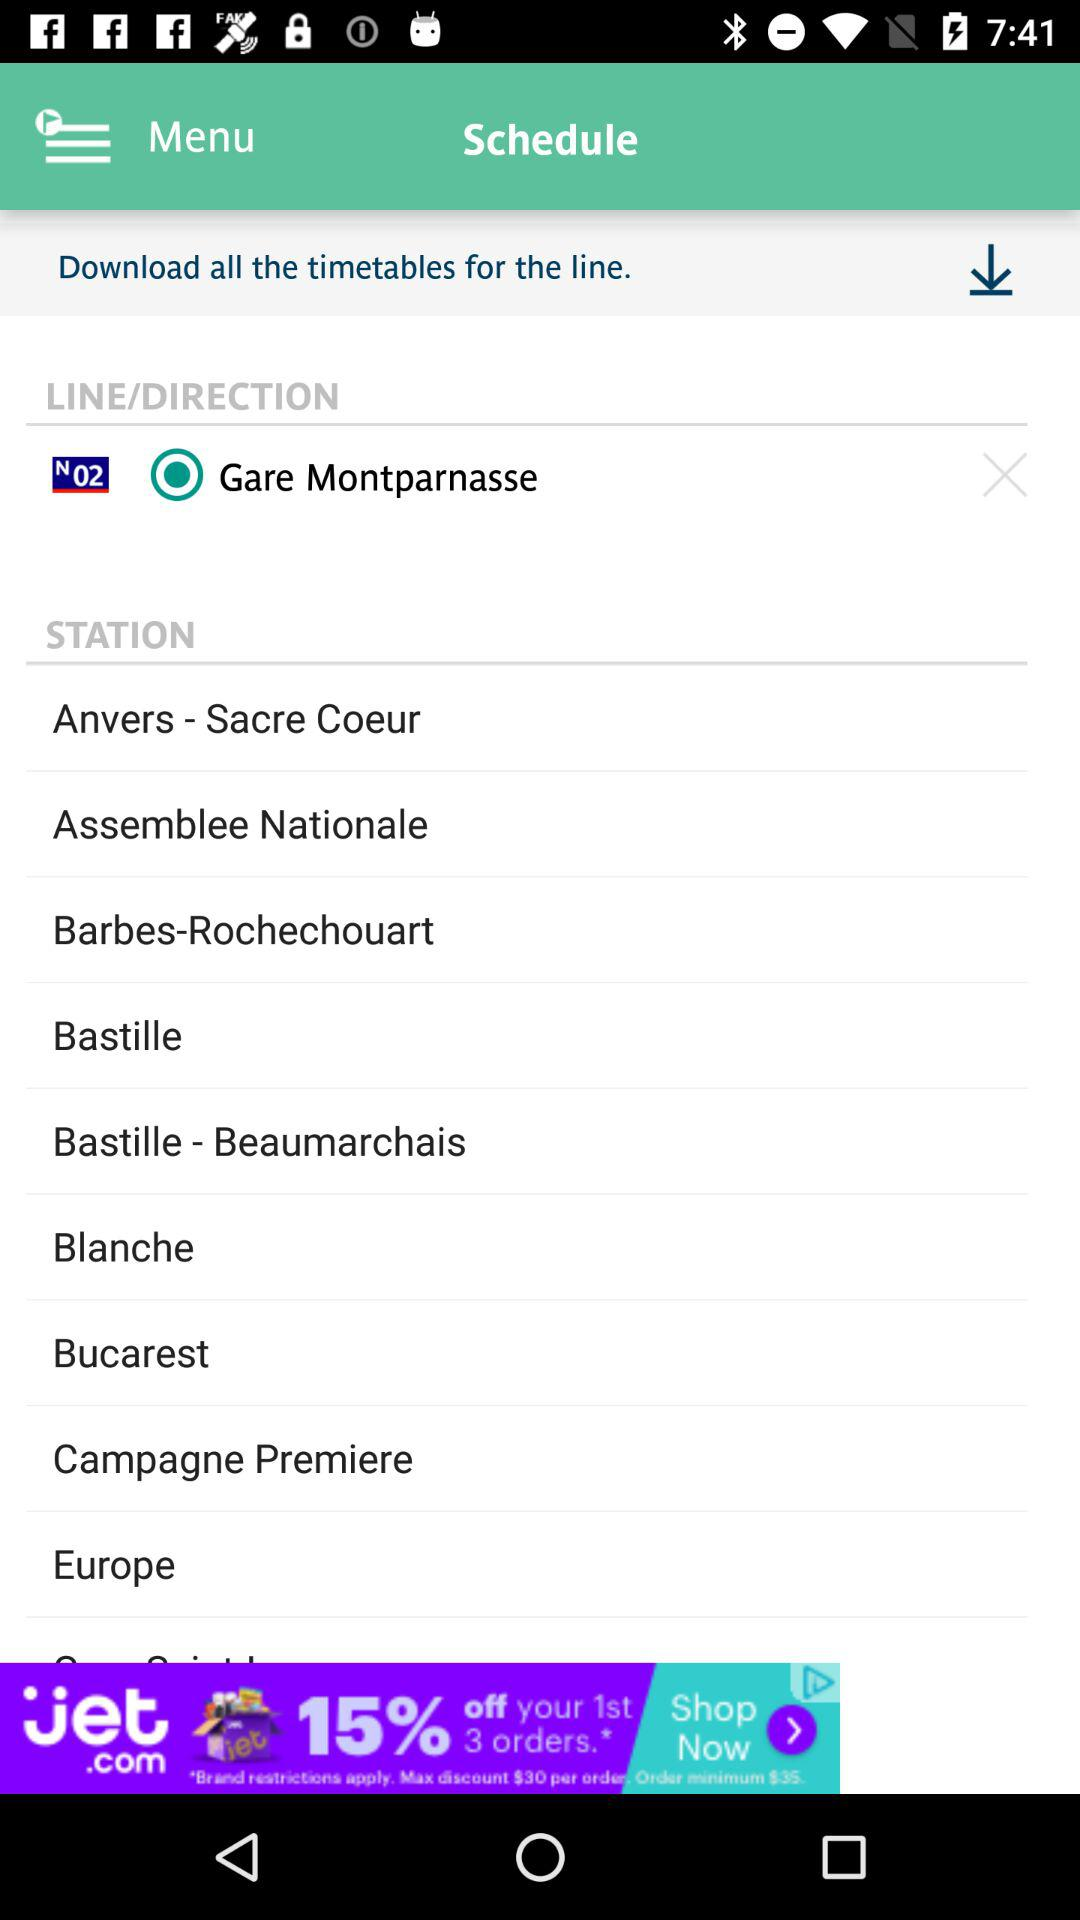What is the status of Gare Montparnasse? The status is "on". 